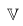Convert formula to latex. <formula><loc_0><loc_0><loc_500><loc_500>\mathbb { V }</formula> 